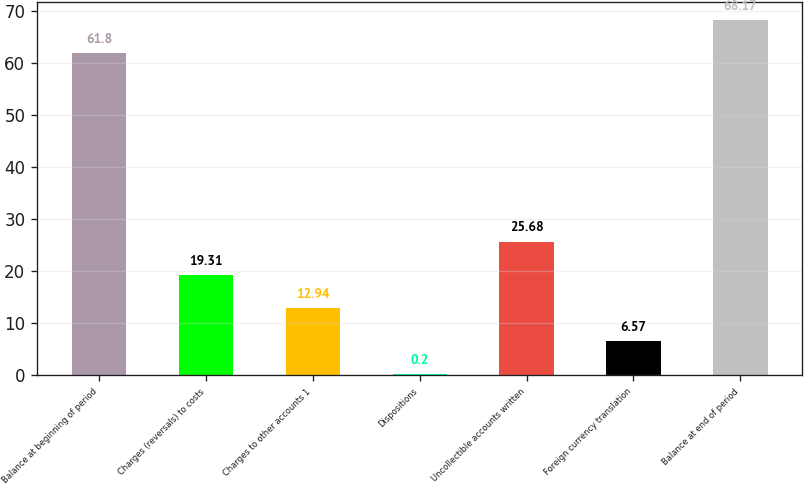Convert chart to OTSL. <chart><loc_0><loc_0><loc_500><loc_500><bar_chart><fcel>Balance at beginning of period<fcel>Charges (reversals) to costs<fcel>Charges to other accounts 1<fcel>Dispositions<fcel>Uncollectible accounts written<fcel>Foreign currency translation<fcel>Balance at end of period<nl><fcel>61.8<fcel>19.31<fcel>12.94<fcel>0.2<fcel>25.68<fcel>6.57<fcel>68.17<nl></chart> 